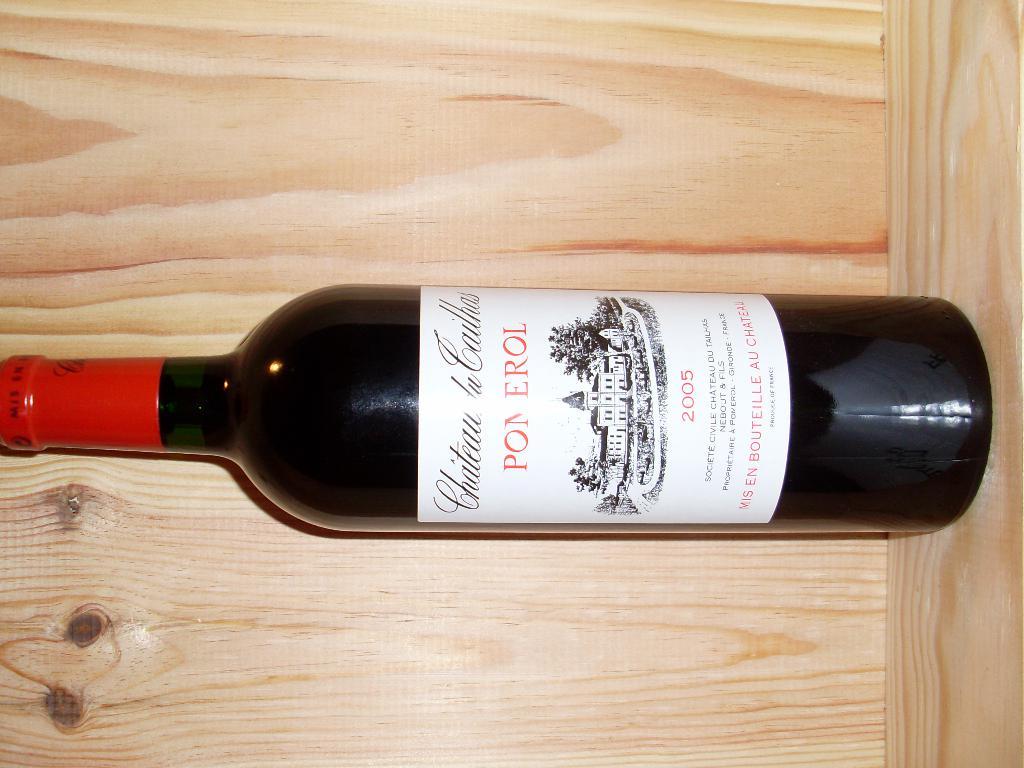What is the year?
Keep it short and to the point. 2005. 